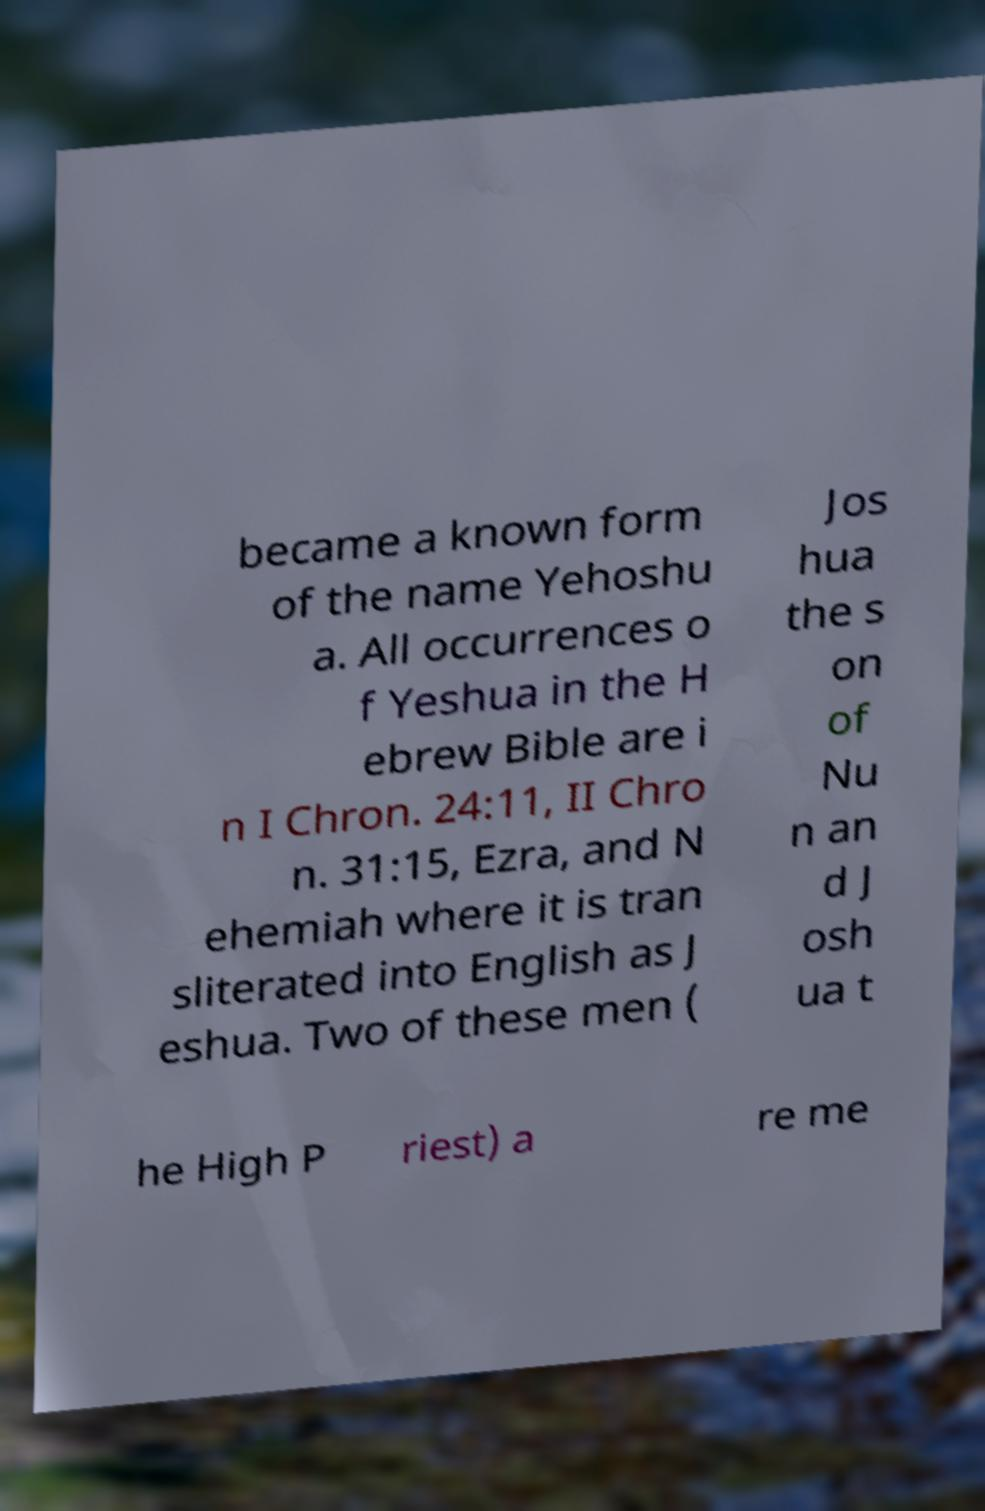There's text embedded in this image that I need extracted. Can you transcribe it verbatim? became a known form of the name Yehoshu a. All occurrences o f Yeshua in the H ebrew Bible are i n I Chron. 24:11, II Chro n. 31:15, Ezra, and N ehemiah where it is tran sliterated into English as J eshua. Two of these men ( Jos hua the s on of Nu n an d J osh ua t he High P riest) a re me 